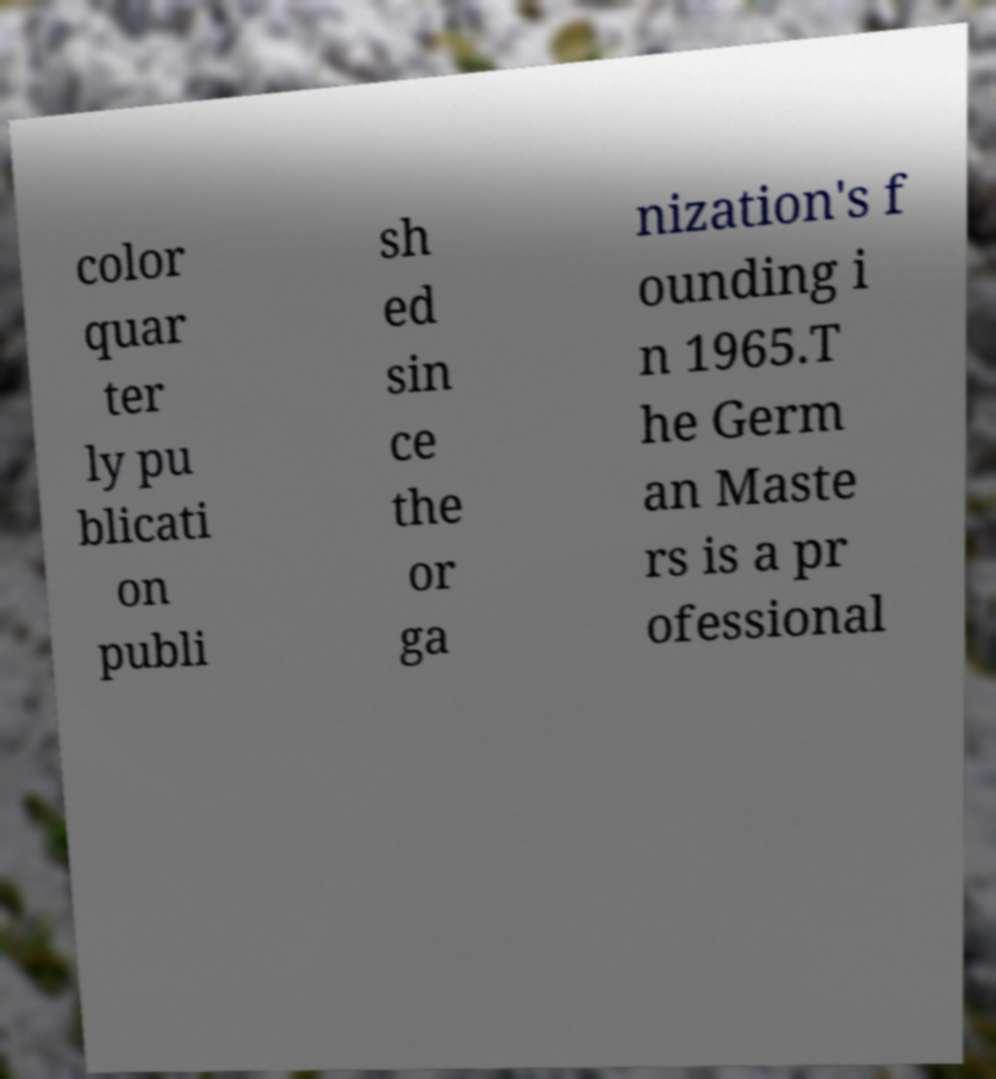Please identify and transcribe the text found in this image. color quar ter ly pu blicati on publi sh ed sin ce the or ga nization's f ounding i n 1965.T he Germ an Maste rs is a pr ofessional 